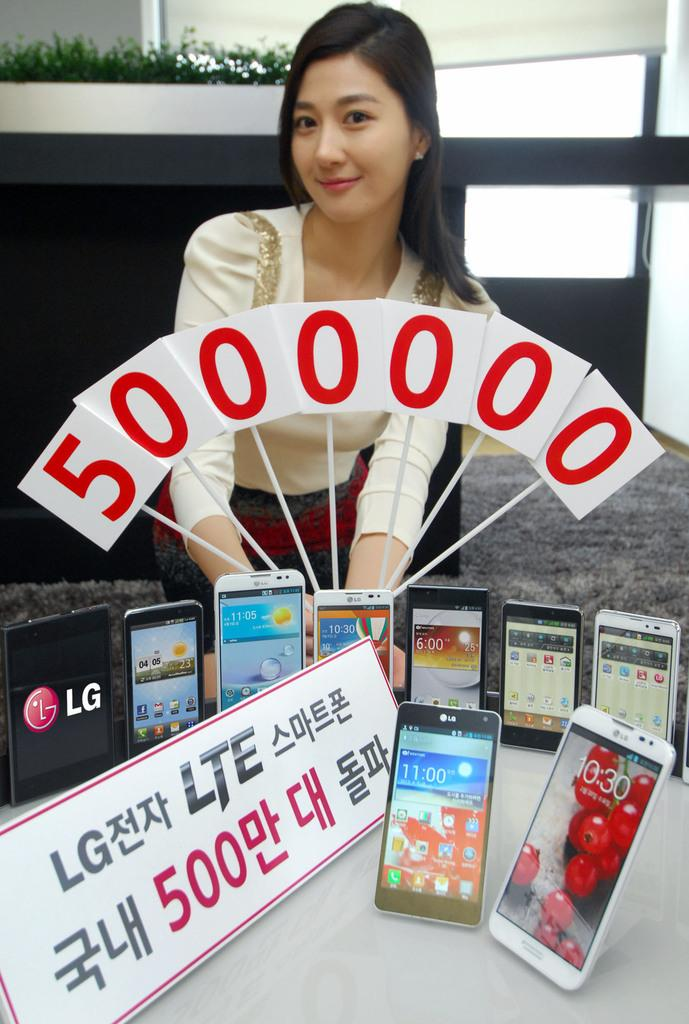<image>
Write a terse but informative summary of the picture. A display table of LG LTE cells and an oriental girl holding white flags with red ink an amount of money for the price of the phones . 